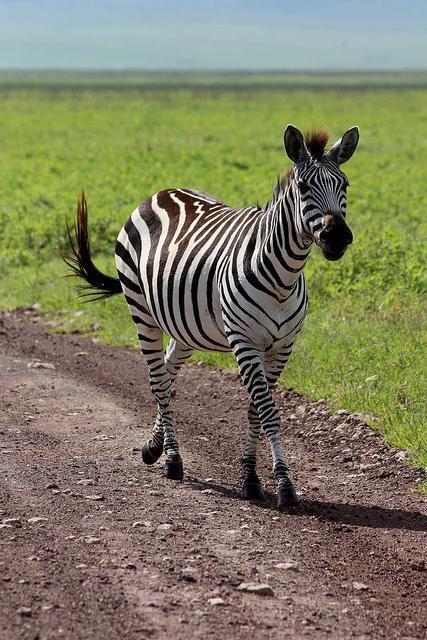How many animals are shown?
Give a very brief answer. 1. 